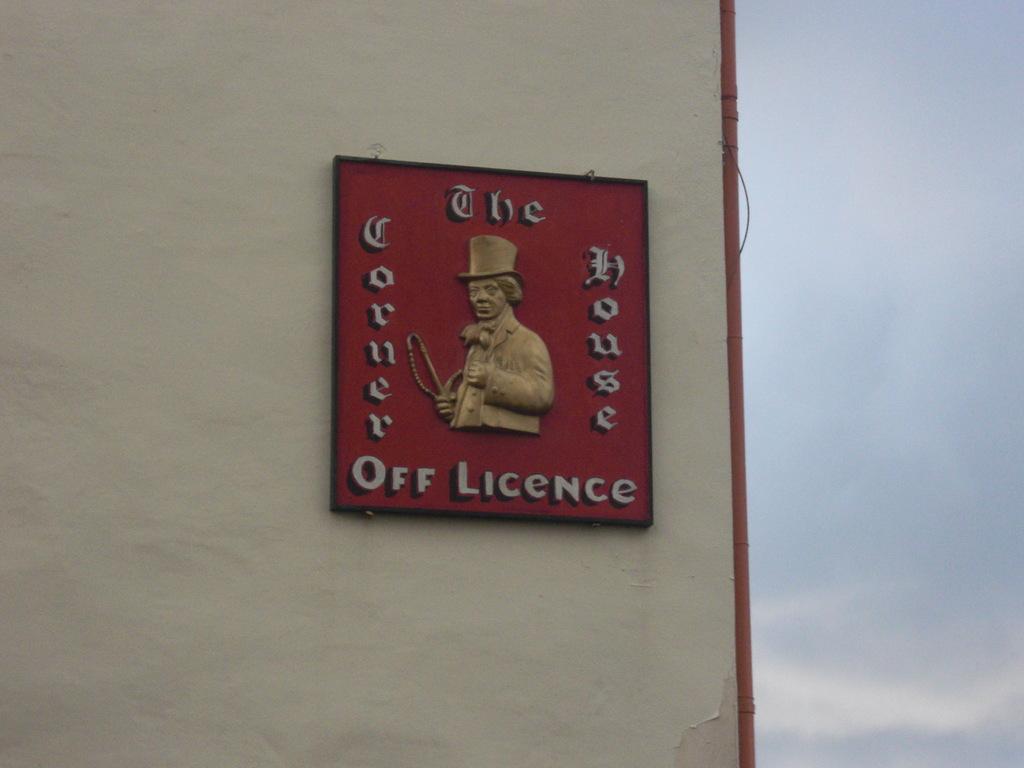What is the name of this house?
Offer a terse response. The corner house. What is mentioned at the bottom?
Provide a short and direct response. Off licence. 